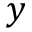<formula> <loc_0><loc_0><loc_500><loc_500>y</formula> 